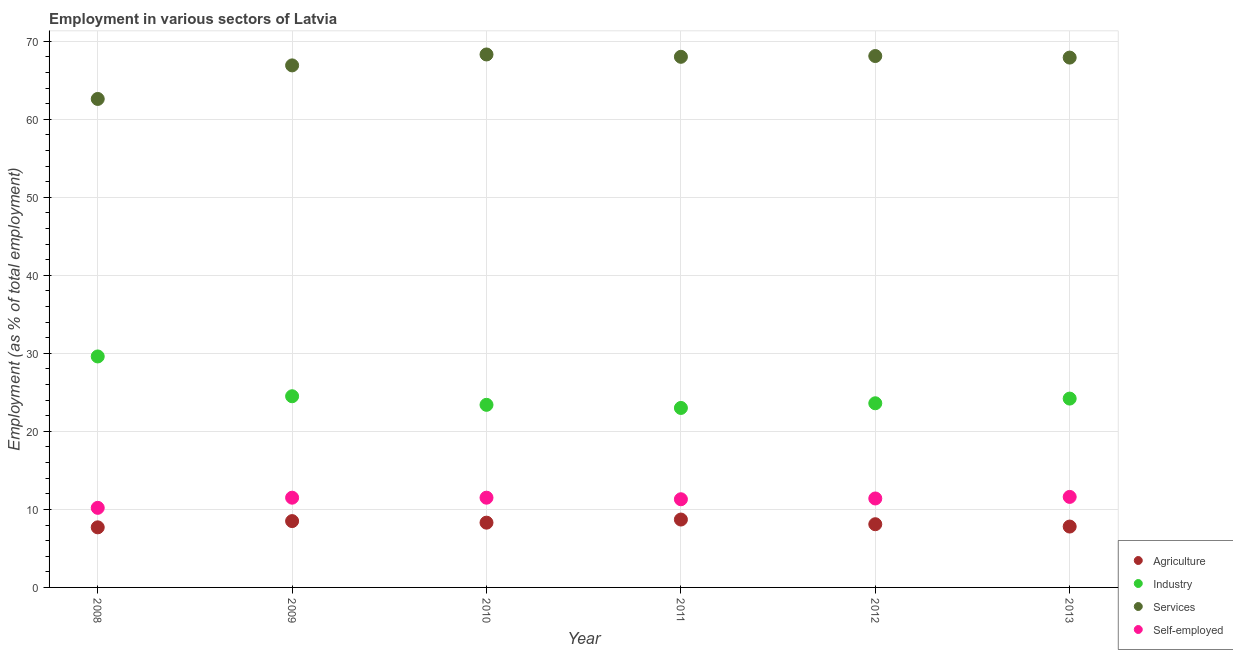How many different coloured dotlines are there?
Your response must be concise. 4. Is the number of dotlines equal to the number of legend labels?
Provide a succinct answer. Yes. What is the percentage of workers in industry in 2008?
Keep it short and to the point. 29.6. Across all years, what is the maximum percentage of self employed workers?
Your response must be concise. 11.6. Across all years, what is the minimum percentage of workers in industry?
Provide a succinct answer. 23. In which year was the percentage of workers in agriculture maximum?
Give a very brief answer. 2011. In which year was the percentage of workers in agriculture minimum?
Your response must be concise. 2008. What is the total percentage of self employed workers in the graph?
Offer a very short reply. 67.5. What is the difference between the percentage of self employed workers in 2008 and that in 2012?
Your response must be concise. -1.2. What is the difference between the percentage of workers in agriculture in 2010 and the percentage of workers in services in 2008?
Your answer should be very brief. -54.3. What is the average percentage of workers in agriculture per year?
Make the answer very short. 8.18. In the year 2008, what is the difference between the percentage of workers in agriculture and percentage of workers in industry?
Make the answer very short. -21.9. In how many years, is the percentage of workers in services greater than 46 %?
Offer a very short reply. 6. What is the ratio of the percentage of workers in industry in 2009 to that in 2011?
Make the answer very short. 1.07. What is the difference between the highest and the second highest percentage of workers in services?
Make the answer very short. 0.2. What is the difference between the highest and the lowest percentage of workers in agriculture?
Your answer should be compact. 1. In how many years, is the percentage of workers in industry greater than the average percentage of workers in industry taken over all years?
Ensure brevity in your answer.  1. Is it the case that in every year, the sum of the percentage of workers in agriculture and percentage of workers in services is greater than the sum of percentage of workers in industry and percentage of self employed workers?
Ensure brevity in your answer.  Yes. Is the percentage of workers in services strictly greater than the percentage of workers in industry over the years?
Ensure brevity in your answer.  Yes. How many years are there in the graph?
Ensure brevity in your answer.  6. What is the difference between two consecutive major ticks on the Y-axis?
Make the answer very short. 10. Does the graph contain grids?
Offer a very short reply. Yes. Where does the legend appear in the graph?
Provide a succinct answer. Bottom right. How many legend labels are there?
Provide a short and direct response. 4. What is the title of the graph?
Give a very brief answer. Employment in various sectors of Latvia. Does "Corruption" appear as one of the legend labels in the graph?
Make the answer very short. No. What is the label or title of the X-axis?
Provide a succinct answer. Year. What is the label or title of the Y-axis?
Your answer should be very brief. Employment (as % of total employment). What is the Employment (as % of total employment) of Agriculture in 2008?
Provide a succinct answer. 7.7. What is the Employment (as % of total employment) of Industry in 2008?
Ensure brevity in your answer.  29.6. What is the Employment (as % of total employment) in Services in 2008?
Ensure brevity in your answer.  62.6. What is the Employment (as % of total employment) in Self-employed in 2008?
Ensure brevity in your answer.  10.2. What is the Employment (as % of total employment) of Services in 2009?
Give a very brief answer. 66.9. What is the Employment (as % of total employment) of Self-employed in 2009?
Keep it short and to the point. 11.5. What is the Employment (as % of total employment) of Agriculture in 2010?
Your response must be concise. 8.3. What is the Employment (as % of total employment) in Industry in 2010?
Keep it short and to the point. 23.4. What is the Employment (as % of total employment) of Services in 2010?
Provide a succinct answer. 68.3. What is the Employment (as % of total employment) of Agriculture in 2011?
Make the answer very short. 8.7. What is the Employment (as % of total employment) in Self-employed in 2011?
Your answer should be compact. 11.3. What is the Employment (as % of total employment) of Agriculture in 2012?
Provide a succinct answer. 8.1. What is the Employment (as % of total employment) in Industry in 2012?
Your response must be concise. 23.6. What is the Employment (as % of total employment) in Services in 2012?
Offer a terse response. 68.1. What is the Employment (as % of total employment) of Self-employed in 2012?
Provide a succinct answer. 11.4. What is the Employment (as % of total employment) of Agriculture in 2013?
Keep it short and to the point. 7.8. What is the Employment (as % of total employment) in Industry in 2013?
Your answer should be very brief. 24.2. What is the Employment (as % of total employment) in Services in 2013?
Offer a very short reply. 67.9. What is the Employment (as % of total employment) of Self-employed in 2013?
Provide a succinct answer. 11.6. Across all years, what is the maximum Employment (as % of total employment) in Agriculture?
Your answer should be very brief. 8.7. Across all years, what is the maximum Employment (as % of total employment) in Industry?
Offer a very short reply. 29.6. Across all years, what is the maximum Employment (as % of total employment) of Services?
Offer a terse response. 68.3. Across all years, what is the maximum Employment (as % of total employment) in Self-employed?
Your response must be concise. 11.6. Across all years, what is the minimum Employment (as % of total employment) of Agriculture?
Your response must be concise. 7.7. Across all years, what is the minimum Employment (as % of total employment) of Industry?
Your answer should be compact. 23. Across all years, what is the minimum Employment (as % of total employment) in Services?
Your response must be concise. 62.6. Across all years, what is the minimum Employment (as % of total employment) of Self-employed?
Offer a very short reply. 10.2. What is the total Employment (as % of total employment) of Agriculture in the graph?
Your answer should be compact. 49.1. What is the total Employment (as % of total employment) in Industry in the graph?
Provide a succinct answer. 148.3. What is the total Employment (as % of total employment) of Services in the graph?
Your answer should be very brief. 401.8. What is the total Employment (as % of total employment) in Self-employed in the graph?
Make the answer very short. 67.5. What is the difference between the Employment (as % of total employment) in Agriculture in 2008 and that in 2009?
Make the answer very short. -0.8. What is the difference between the Employment (as % of total employment) in Self-employed in 2008 and that in 2009?
Your answer should be compact. -1.3. What is the difference between the Employment (as % of total employment) of Agriculture in 2008 and that in 2010?
Your answer should be compact. -0.6. What is the difference between the Employment (as % of total employment) of Industry in 2008 and that in 2010?
Your answer should be compact. 6.2. What is the difference between the Employment (as % of total employment) of Agriculture in 2008 and that in 2011?
Make the answer very short. -1. What is the difference between the Employment (as % of total employment) of Industry in 2008 and that in 2011?
Make the answer very short. 6.6. What is the difference between the Employment (as % of total employment) in Services in 2008 and that in 2012?
Provide a short and direct response. -5.5. What is the difference between the Employment (as % of total employment) of Agriculture in 2008 and that in 2013?
Give a very brief answer. -0.1. What is the difference between the Employment (as % of total employment) in Industry in 2008 and that in 2013?
Keep it short and to the point. 5.4. What is the difference between the Employment (as % of total employment) in Agriculture in 2009 and that in 2010?
Offer a terse response. 0.2. What is the difference between the Employment (as % of total employment) of Agriculture in 2009 and that in 2011?
Ensure brevity in your answer.  -0.2. What is the difference between the Employment (as % of total employment) in Self-employed in 2009 and that in 2011?
Your answer should be compact. 0.2. What is the difference between the Employment (as % of total employment) of Industry in 2009 and that in 2012?
Your answer should be very brief. 0.9. What is the difference between the Employment (as % of total employment) in Services in 2009 and that in 2012?
Give a very brief answer. -1.2. What is the difference between the Employment (as % of total employment) in Self-employed in 2009 and that in 2012?
Provide a succinct answer. 0.1. What is the difference between the Employment (as % of total employment) of Self-employed in 2009 and that in 2013?
Ensure brevity in your answer.  -0.1. What is the difference between the Employment (as % of total employment) of Industry in 2010 and that in 2011?
Give a very brief answer. 0.4. What is the difference between the Employment (as % of total employment) in Services in 2010 and that in 2011?
Your response must be concise. 0.3. What is the difference between the Employment (as % of total employment) in Self-employed in 2010 and that in 2011?
Ensure brevity in your answer.  0.2. What is the difference between the Employment (as % of total employment) of Self-employed in 2010 and that in 2012?
Give a very brief answer. 0.1. What is the difference between the Employment (as % of total employment) of Self-employed in 2010 and that in 2013?
Your answer should be very brief. -0.1. What is the difference between the Employment (as % of total employment) of Industry in 2011 and that in 2012?
Offer a terse response. -0.6. What is the difference between the Employment (as % of total employment) of Industry in 2011 and that in 2013?
Provide a short and direct response. -1.2. What is the difference between the Employment (as % of total employment) in Agriculture in 2012 and that in 2013?
Provide a succinct answer. 0.3. What is the difference between the Employment (as % of total employment) of Industry in 2012 and that in 2013?
Offer a very short reply. -0.6. What is the difference between the Employment (as % of total employment) in Agriculture in 2008 and the Employment (as % of total employment) in Industry in 2009?
Keep it short and to the point. -16.8. What is the difference between the Employment (as % of total employment) in Agriculture in 2008 and the Employment (as % of total employment) in Services in 2009?
Provide a short and direct response. -59.2. What is the difference between the Employment (as % of total employment) of Agriculture in 2008 and the Employment (as % of total employment) of Self-employed in 2009?
Your answer should be very brief. -3.8. What is the difference between the Employment (as % of total employment) in Industry in 2008 and the Employment (as % of total employment) in Services in 2009?
Offer a very short reply. -37.3. What is the difference between the Employment (as % of total employment) in Industry in 2008 and the Employment (as % of total employment) in Self-employed in 2009?
Your answer should be very brief. 18.1. What is the difference between the Employment (as % of total employment) in Services in 2008 and the Employment (as % of total employment) in Self-employed in 2009?
Make the answer very short. 51.1. What is the difference between the Employment (as % of total employment) of Agriculture in 2008 and the Employment (as % of total employment) of Industry in 2010?
Provide a short and direct response. -15.7. What is the difference between the Employment (as % of total employment) of Agriculture in 2008 and the Employment (as % of total employment) of Services in 2010?
Provide a succinct answer. -60.6. What is the difference between the Employment (as % of total employment) of Industry in 2008 and the Employment (as % of total employment) of Services in 2010?
Ensure brevity in your answer.  -38.7. What is the difference between the Employment (as % of total employment) in Industry in 2008 and the Employment (as % of total employment) in Self-employed in 2010?
Offer a terse response. 18.1. What is the difference between the Employment (as % of total employment) in Services in 2008 and the Employment (as % of total employment) in Self-employed in 2010?
Provide a short and direct response. 51.1. What is the difference between the Employment (as % of total employment) in Agriculture in 2008 and the Employment (as % of total employment) in Industry in 2011?
Your answer should be compact. -15.3. What is the difference between the Employment (as % of total employment) of Agriculture in 2008 and the Employment (as % of total employment) of Services in 2011?
Keep it short and to the point. -60.3. What is the difference between the Employment (as % of total employment) in Industry in 2008 and the Employment (as % of total employment) in Services in 2011?
Give a very brief answer. -38.4. What is the difference between the Employment (as % of total employment) in Industry in 2008 and the Employment (as % of total employment) in Self-employed in 2011?
Your answer should be very brief. 18.3. What is the difference between the Employment (as % of total employment) of Services in 2008 and the Employment (as % of total employment) of Self-employed in 2011?
Ensure brevity in your answer.  51.3. What is the difference between the Employment (as % of total employment) of Agriculture in 2008 and the Employment (as % of total employment) of Industry in 2012?
Give a very brief answer. -15.9. What is the difference between the Employment (as % of total employment) in Agriculture in 2008 and the Employment (as % of total employment) in Services in 2012?
Provide a short and direct response. -60.4. What is the difference between the Employment (as % of total employment) in Industry in 2008 and the Employment (as % of total employment) in Services in 2012?
Provide a succinct answer. -38.5. What is the difference between the Employment (as % of total employment) of Industry in 2008 and the Employment (as % of total employment) of Self-employed in 2012?
Provide a succinct answer. 18.2. What is the difference between the Employment (as % of total employment) of Services in 2008 and the Employment (as % of total employment) of Self-employed in 2012?
Your answer should be very brief. 51.2. What is the difference between the Employment (as % of total employment) of Agriculture in 2008 and the Employment (as % of total employment) of Industry in 2013?
Your answer should be very brief. -16.5. What is the difference between the Employment (as % of total employment) in Agriculture in 2008 and the Employment (as % of total employment) in Services in 2013?
Offer a terse response. -60.2. What is the difference between the Employment (as % of total employment) of Industry in 2008 and the Employment (as % of total employment) of Services in 2013?
Offer a terse response. -38.3. What is the difference between the Employment (as % of total employment) in Services in 2008 and the Employment (as % of total employment) in Self-employed in 2013?
Offer a terse response. 51. What is the difference between the Employment (as % of total employment) in Agriculture in 2009 and the Employment (as % of total employment) in Industry in 2010?
Your response must be concise. -14.9. What is the difference between the Employment (as % of total employment) in Agriculture in 2009 and the Employment (as % of total employment) in Services in 2010?
Provide a short and direct response. -59.8. What is the difference between the Employment (as % of total employment) in Industry in 2009 and the Employment (as % of total employment) in Services in 2010?
Your answer should be very brief. -43.8. What is the difference between the Employment (as % of total employment) of Industry in 2009 and the Employment (as % of total employment) of Self-employed in 2010?
Give a very brief answer. 13. What is the difference between the Employment (as % of total employment) of Services in 2009 and the Employment (as % of total employment) of Self-employed in 2010?
Offer a very short reply. 55.4. What is the difference between the Employment (as % of total employment) of Agriculture in 2009 and the Employment (as % of total employment) of Industry in 2011?
Your answer should be compact. -14.5. What is the difference between the Employment (as % of total employment) in Agriculture in 2009 and the Employment (as % of total employment) in Services in 2011?
Offer a very short reply. -59.5. What is the difference between the Employment (as % of total employment) of Industry in 2009 and the Employment (as % of total employment) of Services in 2011?
Your answer should be very brief. -43.5. What is the difference between the Employment (as % of total employment) of Services in 2009 and the Employment (as % of total employment) of Self-employed in 2011?
Your response must be concise. 55.6. What is the difference between the Employment (as % of total employment) in Agriculture in 2009 and the Employment (as % of total employment) in Industry in 2012?
Your response must be concise. -15.1. What is the difference between the Employment (as % of total employment) in Agriculture in 2009 and the Employment (as % of total employment) in Services in 2012?
Your answer should be compact. -59.6. What is the difference between the Employment (as % of total employment) in Industry in 2009 and the Employment (as % of total employment) in Services in 2012?
Offer a very short reply. -43.6. What is the difference between the Employment (as % of total employment) in Services in 2009 and the Employment (as % of total employment) in Self-employed in 2012?
Give a very brief answer. 55.5. What is the difference between the Employment (as % of total employment) of Agriculture in 2009 and the Employment (as % of total employment) of Industry in 2013?
Keep it short and to the point. -15.7. What is the difference between the Employment (as % of total employment) in Agriculture in 2009 and the Employment (as % of total employment) in Services in 2013?
Your answer should be compact. -59.4. What is the difference between the Employment (as % of total employment) of Industry in 2009 and the Employment (as % of total employment) of Services in 2013?
Offer a terse response. -43.4. What is the difference between the Employment (as % of total employment) in Industry in 2009 and the Employment (as % of total employment) in Self-employed in 2013?
Ensure brevity in your answer.  12.9. What is the difference between the Employment (as % of total employment) of Services in 2009 and the Employment (as % of total employment) of Self-employed in 2013?
Your answer should be very brief. 55.3. What is the difference between the Employment (as % of total employment) of Agriculture in 2010 and the Employment (as % of total employment) of Industry in 2011?
Provide a succinct answer. -14.7. What is the difference between the Employment (as % of total employment) of Agriculture in 2010 and the Employment (as % of total employment) of Services in 2011?
Give a very brief answer. -59.7. What is the difference between the Employment (as % of total employment) of Agriculture in 2010 and the Employment (as % of total employment) of Self-employed in 2011?
Your answer should be compact. -3. What is the difference between the Employment (as % of total employment) in Industry in 2010 and the Employment (as % of total employment) in Services in 2011?
Offer a terse response. -44.6. What is the difference between the Employment (as % of total employment) of Services in 2010 and the Employment (as % of total employment) of Self-employed in 2011?
Offer a terse response. 57. What is the difference between the Employment (as % of total employment) of Agriculture in 2010 and the Employment (as % of total employment) of Industry in 2012?
Your answer should be compact. -15.3. What is the difference between the Employment (as % of total employment) in Agriculture in 2010 and the Employment (as % of total employment) in Services in 2012?
Provide a succinct answer. -59.8. What is the difference between the Employment (as % of total employment) in Agriculture in 2010 and the Employment (as % of total employment) in Self-employed in 2012?
Provide a short and direct response. -3.1. What is the difference between the Employment (as % of total employment) in Industry in 2010 and the Employment (as % of total employment) in Services in 2012?
Provide a succinct answer. -44.7. What is the difference between the Employment (as % of total employment) of Industry in 2010 and the Employment (as % of total employment) of Self-employed in 2012?
Keep it short and to the point. 12. What is the difference between the Employment (as % of total employment) of Services in 2010 and the Employment (as % of total employment) of Self-employed in 2012?
Your response must be concise. 56.9. What is the difference between the Employment (as % of total employment) of Agriculture in 2010 and the Employment (as % of total employment) of Industry in 2013?
Keep it short and to the point. -15.9. What is the difference between the Employment (as % of total employment) in Agriculture in 2010 and the Employment (as % of total employment) in Services in 2013?
Provide a succinct answer. -59.6. What is the difference between the Employment (as % of total employment) in Agriculture in 2010 and the Employment (as % of total employment) in Self-employed in 2013?
Offer a terse response. -3.3. What is the difference between the Employment (as % of total employment) of Industry in 2010 and the Employment (as % of total employment) of Services in 2013?
Your response must be concise. -44.5. What is the difference between the Employment (as % of total employment) in Services in 2010 and the Employment (as % of total employment) in Self-employed in 2013?
Your answer should be very brief. 56.7. What is the difference between the Employment (as % of total employment) of Agriculture in 2011 and the Employment (as % of total employment) of Industry in 2012?
Your answer should be compact. -14.9. What is the difference between the Employment (as % of total employment) in Agriculture in 2011 and the Employment (as % of total employment) in Services in 2012?
Give a very brief answer. -59.4. What is the difference between the Employment (as % of total employment) in Agriculture in 2011 and the Employment (as % of total employment) in Self-employed in 2012?
Keep it short and to the point. -2.7. What is the difference between the Employment (as % of total employment) of Industry in 2011 and the Employment (as % of total employment) of Services in 2012?
Your answer should be very brief. -45.1. What is the difference between the Employment (as % of total employment) of Services in 2011 and the Employment (as % of total employment) of Self-employed in 2012?
Offer a very short reply. 56.6. What is the difference between the Employment (as % of total employment) in Agriculture in 2011 and the Employment (as % of total employment) in Industry in 2013?
Ensure brevity in your answer.  -15.5. What is the difference between the Employment (as % of total employment) in Agriculture in 2011 and the Employment (as % of total employment) in Services in 2013?
Give a very brief answer. -59.2. What is the difference between the Employment (as % of total employment) of Industry in 2011 and the Employment (as % of total employment) of Services in 2013?
Offer a terse response. -44.9. What is the difference between the Employment (as % of total employment) of Industry in 2011 and the Employment (as % of total employment) of Self-employed in 2013?
Provide a succinct answer. 11.4. What is the difference between the Employment (as % of total employment) of Services in 2011 and the Employment (as % of total employment) of Self-employed in 2013?
Your answer should be very brief. 56.4. What is the difference between the Employment (as % of total employment) of Agriculture in 2012 and the Employment (as % of total employment) of Industry in 2013?
Your response must be concise. -16.1. What is the difference between the Employment (as % of total employment) of Agriculture in 2012 and the Employment (as % of total employment) of Services in 2013?
Your response must be concise. -59.8. What is the difference between the Employment (as % of total employment) of Industry in 2012 and the Employment (as % of total employment) of Services in 2013?
Your answer should be very brief. -44.3. What is the difference between the Employment (as % of total employment) in Industry in 2012 and the Employment (as % of total employment) in Self-employed in 2013?
Provide a succinct answer. 12. What is the difference between the Employment (as % of total employment) in Services in 2012 and the Employment (as % of total employment) in Self-employed in 2013?
Provide a succinct answer. 56.5. What is the average Employment (as % of total employment) in Agriculture per year?
Provide a short and direct response. 8.18. What is the average Employment (as % of total employment) of Industry per year?
Give a very brief answer. 24.72. What is the average Employment (as % of total employment) of Services per year?
Offer a very short reply. 66.97. What is the average Employment (as % of total employment) in Self-employed per year?
Offer a very short reply. 11.25. In the year 2008, what is the difference between the Employment (as % of total employment) in Agriculture and Employment (as % of total employment) in Industry?
Your answer should be compact. -21.9. In the year 2008, what is the difference between the Employment (as % of total employment) of Agriculture and Employment (as % of total employment) of Services?
Give a very brief answer. -54.9. In the year 2008, what is the difference between the Employment (as % of total employment) of Industry and Employment (as % of total employment) of Services?
Ensure brevity in your answer.  -33. In the year 2008, what is the difference between the Employment (as % of total employment) in Industry and Employment (as % of total employment) in Self-employed?
Ensure brevity in your answer.  19.4. In the year 2008, what is the difference between the Employment (as % of total employment) in Services and Employment (as % of total employment) in Self-employed?
Your response must be concise. 52.4. In the year 2009, what is the difference between the Employment (as % of total employment) in Agriculture and Employment (as % of total employment) in Services?
Ensure brevity in your answer.  -58.4. In the year 2009, what is the difference between the Employment (as % of total employment) in Agriculture and Employment (as % of total employment) in Self-employed?
Your answer should be very brief. -3. In the year 2009, what is the difference between the Employment (as % of total employment) of Industry and Employment (as % of total employment) of Services?
Offer a very short reply. -42.4. In the year 2009, what is the difference between the Employment (as % of total employment) of Industry and Employment (as % of total employment) of Self-employed?
Keep it short and to the point. 13. In the year 2009, what is the difference between the Employment (as % of total employment) in Services and Employment (as % of total employment) in Self-employed?
Give a very brief answer. 55.4. In the year 2010, what is the difference between the Employment (as % of total employment) in Agriculture and Employment (as % of total employment) in Industry?
Provide a succinct answer. -15.1. In the year 2010, what is the difference between the Employment (as % of total employment) of Agriculture and Employment (as % of total employment) of Services?
Keep it short and to the point. -60. In the year 2010, what is the difference between the Employment (as % of total employment) of Agriculture and Employment (as % of total employment) of Self-employed?
Provide a succinct answer. -3.2. In the year 2010, what is the difference between the Employment (as % of total employment) in Industry and Employment (as % of total employment) in Services?
Offer a terse response. -44.9. In the year 2010, what is the difference between the Employment (as % of total employment) of Services and Employment (as % of total employment) of Self-employed?
Your answer should be compact. 56.8. In the year 2011, what is the difference between the Employment (as % of total employment) of Agriculture and Employment (as % of total employment) of Industry?
Your answer should be very brief. -14.3. In the year 2011, what is the difference between the Employment (as % of total employment) of Agriculture and Employment (as % of total employment) of Services?
Keep it short and to the point. -59.3. In the year 2011, what is the difference between the Employment (as % of total employment) in Industry and Employment (as % of total employment) in Services?
Keep it short and to the point. -45. In the year 2011, what is the difference between the Employment (as % of total employment) in Industry and Employment (as % of total employment) in Self-employed?
Offer a terse response. 11.7. In the year 2011, what is the difference between the Employment (as % of total employment) of Services and Employment (as % of total employment) of Self-employed?
Offer a terse response. 56.7. In the year 2012, what is the difference between the Employment (as % of total employment) of Agriculture and Employment (as % of total employment) of Industry?
Ensure brevity in your answer.  -15.5. In the year 2012, what is the difference between the Employment (as % of total employment) in Agriculture and Employment (as % of total employment) in Services?
Give a very brief answer. -60. In the year 2012, what is the difference between the Employment (as % of total employment) in Agriculture and Employment (as % of total employment) in Self-employed?
Your response must be concise. -3.3. In the year 2012, what is the difference between the Employment (as % of total employment) in Industry and Employment (as % of total employment) in Services?
Offer a terse response. -44.5. In the year 2012, what is the difference between the Employment (as % of total employment) of Industry and Employment (as % of total employment) of Self-employed?
Give a very brief answer. 12.2. In the year 2012, what is the difference between the Employment (as % of total employment) in Services and Employment (as % of total employment) in Self-employed?
Your answer should be very brief. 56.7. In the year 2013, what is the difference between the Employment (as % of total employment) in Agriculture and Employment (as % of total employment) in Industry?
Your answer should be very brief. -16.4. In the year 2013, what is the difference between the Employment (as % of total employment) in Agriculture and Employment (as % of total employment) in Services?
Offer a terse response. -60.1. In the year 2013, what is the difference between the Employment (as % of total employment) in Agriculture and Employment (as % of total employment) in Self-employed?
Offer a very short reply. -3.8. In the year 2013, what is the difference between the Employment (as % of total employment) of Industry and Employment (as % of total employment) of Services?
Ensure brevity in your answer.  -43.7. In the year 2013, what is the difference between the Employment (as % of total employment) of Industry and Employment (as % of total employment) of Self-employed?
Keep it short and to the point. 12.6. In the year 2013, what is the difference between the Employment (as % of total employment) in Services and Employment (as % of total employment) in Self-employed?
Provide a succinct answer. 56.3. What is the ratio of the Employment (as % of total employment) in Agriculture in 2008 to that in 2009?
Offer a terse response. 0.91. What is the ratio of the Employment (as % of total employment) in Industry in 2008 to that in 2009?
Provide a succinct answer. 1.21. What is the ratio of the Employment (as % of total employment) of Services in 2008 to that in 2009?
Offer a very short reply. 0.94. What is the ratio of the Employment (as % of total employment) of Self-employed in 2008 to that in 2009?
Offer a terse response. 0.89. What is the ratio of the Employment (as % of total employment) in Agriculture in 2008 to that in 2010?
Provide a succinct answer. 0.93. What is the ratio of the Employment (as % of total employment) in Industry in 2008 to that in 2010?
Your answer should be compact. 1.26. What is the ratio of the Employment (as % of total employment) of Services in 2008 to that in 2010?
Provide a short and direct response. 0.92. What is the ratio of the Employment (as % of total employment) in Self-employed in 2008 to that in 2010?
Ensure brevity in your answer.  0.89. What is the ratio of the Employment (as % of total employment) of Agriculture in 2008 to that in 2011?
Your answer should be very brief. 0.89. What is the ratio of the Employment (as % of total employment) in Industry in 2008 to that in 2011?
Make the answer very short. 1.29. What is the ratio of the Employment (as % of total employment) in Services in 2008 to that in 2011?
Your answer should be compact. 0.92. What is the ratio of the Employment (as % of total employment) of Self-employed in 2008 to that in 2011?
Your answer should be very brief. 0.9. What is the ratio of the Employment (as % of total employment) in Agriculture in 2008 to that in 2012?
Ensure brevity in your answer.  0.95. What is the ratio of the Employment (as % of total employment) in Industry in 2008 to that in 2012?
Give a very brief answer. 1.25. What is the ratio of the Employment (as % of total employment) of Services in 2008 to that in 2012?
Provide a succinct answer. 0.92. What is the ratio of the Employment (as % of total employment) in Self-employed in 2008 to that in 2012?
Keep it short and to the point. 0.89. What is the ratio of the Employment (as % of total employment) of Agriculture in 2008 to that in 2013?
Offer a terse response. 0.99. What is the ratio of the Employment (as % of total employment) in Industry in 2008 to that in 2013?
Offer a terse response. 1.22. What is the ratio of the Employment (as % of total employment) in Services in 2008 to that in 2013?
Keep it short and to the point. 0.92. What is the ratio of the Employment (as % of total employment) in Self-employed in 2008 to that in 2013?
Make the answer very short. 0.88. What is the ratio of the Employment (as % of total employment) in Agriculture in 2009 to that in 2010?
Provide a short and direct response. 1.02. What is the ratio of the Employment (as % of total employment) of Industry in 2009 to that in 2010?
Your response must be concise. 1.05. What is the ratio of the Employment (as % of total employment) in Services in 2009 to that in 2010?
Your response must be concise. 0.98. What is the ratio of the Employment (as % of total employment) of Industry in 2009 to that in 2011?
Provide a succinct answer. 1.07. What is the ratio of the Employment (as % of total employment) of Services in 2009 to that in 2011?
Your response must be concise. 0.98. What is the ratio of the Employment (as % of total employment) in Self-employed in 2009 to that in 2011?
Ensure brevity in your answer.  1.02. What is the ratio of the Employment (as % of total employment) in Agriculture in 2009 to that in 2012?
Offer a very short reply. 1.05. What is the ratio of the Employment (as % of total employment) in Industry in 2009 to that in 2012?
Give a very brief answer. 1.04. What is the ratio of the Employment (as % of total employment) in Services in 2009 to that in 2012?
Keep it short and to the point. 0.98. What is the ratio of the Employment (as % of total employment) of Self-employed in 2009 to that in 2012?
Offer a terse response. 1.01. What is the ratio of the Employment (as % of total employment) of Agriculture in 2009 to that in 2013?
Make the answer very short. 1.09. What is the ratio of the Employment (as % of total employment) in Industry in 2009 to that in 2013?
Provide a succinct answer. 1.01. What is the ratio of the Employment (as % of total employment) of Services in 2009 to that in 2013?
Your response must be concise. 0.99. What is the ratio of the Employment (as % of total employment) of Agriculture in 2010 to that in 2011?
Provide a short and direct response. 0.95. What is the ratio of the Employment (as % of total employment) in Industry in 2010 to that in 2011?
Your answer should be very brief. 1.02. What is the ratio of the Employment (as % of total employment) in Services in 2010 to that in 2011?
Your response must be concise. 1. What is the ratio of the Employment (as % of total employment) of Self-employed in 2010 to that in 2011?
Your answer should be very brief. 1.02. What is the ratio of the Employment (as % of total employment) in Agriculture in 2010 to that in 2012?
Give a very brief answer. 1.02. What is the ratio of the Employment (as % of total employment) of Services in 2010 to that in 2012?
Ensure brevity in your answer.  1. What is the ratio of the Employment (as % of total employment) of Self-employed in 2010 to that in 2012?
Your response must be concise. 1.01. What is the ratio of the Employment (as % of total employment) of Agriculture in 2010 to that in 2013?
Your response must be concise. 1.06. What is the ratio of the Employment (as % of total employment) in Industry in 2010 to that in 2013?
Make the answer very short. 0.97. What is the ratio of the Employment (as % of total employment) of Services in 2010 to that in 2013?
Your answer should be compact. 1.01. What is the ratio of the Employment (as % of total employment) of Agriculture in 2011 to that in 2012?
Provide a succinct answer. 1.07. What is the ratio of the Employment (as % of total employment) in Industry in 2011 to that in 2012?
Your answer should be compact. 0.97. What is the ratio of the Employment (as % of total employment) of Services in 2011 to that in 2012?
Your answer should be very brief. 1. What is the ratio of the Employment (as % of total employment) in Self-employed in 2011 to that in 2012?
Ensure brevity in your answer.  0.99. What is the ratio of the Employment (as % of total employment) of Agriculture in 2011 to that in 2013?
Provide a short and direct response. 1.12. What is the ratio of the Employment (as % of total employment) in Industry in 2011 to that in 2013?
Ensure brevity in your answer.  0.95. What is the ratio of the Employment (as % of total employment) in Self-employed in 2011 to that in 2013?
Keep it short and to the point. 0.97. What is the ratio of the Employment (as % of total employment) in Agriculture in 2012 to that in 2013?
Your answer should be compact. 1.04. What is the ratio of the Employment (as % of total employment) in Industry in 2012 to that in 2013?
Your answer should be compact. 0.98. What is the ratio of the Employment (as % of total employment) in Self-employed in 2012 to that in 2013?
Keep it short and to the point. 0.98. 